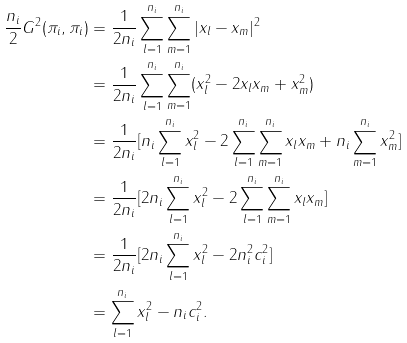Convert formula to latex. <formula><loc_0><loc_0><loc_500><loc_500>\frac { n _ { i } } { 2 } G ^ { 2 } ( \pi _ { i } , \pi _ { i } ) & = \frac { 1 } { 2 n _ { i } } \sum _ { l = 1 } ^ { n _ { i } } \sum _ { m = 1 } ^ { n _ { i } } | x _ { l } - x _ { m } | ^ { 2 } \\ & = \frac { 1 } { 2 n _ { i } } \sum _ { l = 1 } ^ { n _ { i } } \sum _ { m = 1 } ^ { n _ { i } } ( x _ { l } ^ { 2 } - 2 x _ { l } x _ { m } + x _ { m } ^ { 2 } ) \\ & = \frac { 1 } { 2 n _ { i } } [ n _ { i } \sum _ { l = 1 } ^ { n _ { i } } x _ { l } ^ { 2 } - 2 \sum _ { l = 1 } ^ { n _ { i } } \sum _ { m = 1 } ^ { n _ { i } } x _ { l } x _ { m } + n _ { i } \sum _ { m = 1 } ^ { n _ { i } } x _ { m } ^ { 2 } ] \\ & = \frac { 1 } { 2 n _ { i } } [ 2 n _ { i } \sum _ { l = 1 } ^ { n _ { i } } x _ { l } ^ { 2 } - 2 \sum _ { l = 1 } ^ { n _ { i } } \sum _ { m = 1 } ^ { n _ { i } } x _ { l } x _ { m } ] \\ & = \frac { 1 } { 2 n _ { i } } [ 2 n _ { i } \sum _ { l = 1 } ^ { n _ { i } } x _ { l } ^ { 2 } - 2 n _ { i } ^ { 2 } c _ { i } ^ { 2 } ] \\ & = \sum ^ { n _ { i } } _ { l = 1 } x _ { l } ^ { 2 } - n _ { i } c _ { i } ^ { 2 } .</formula> 